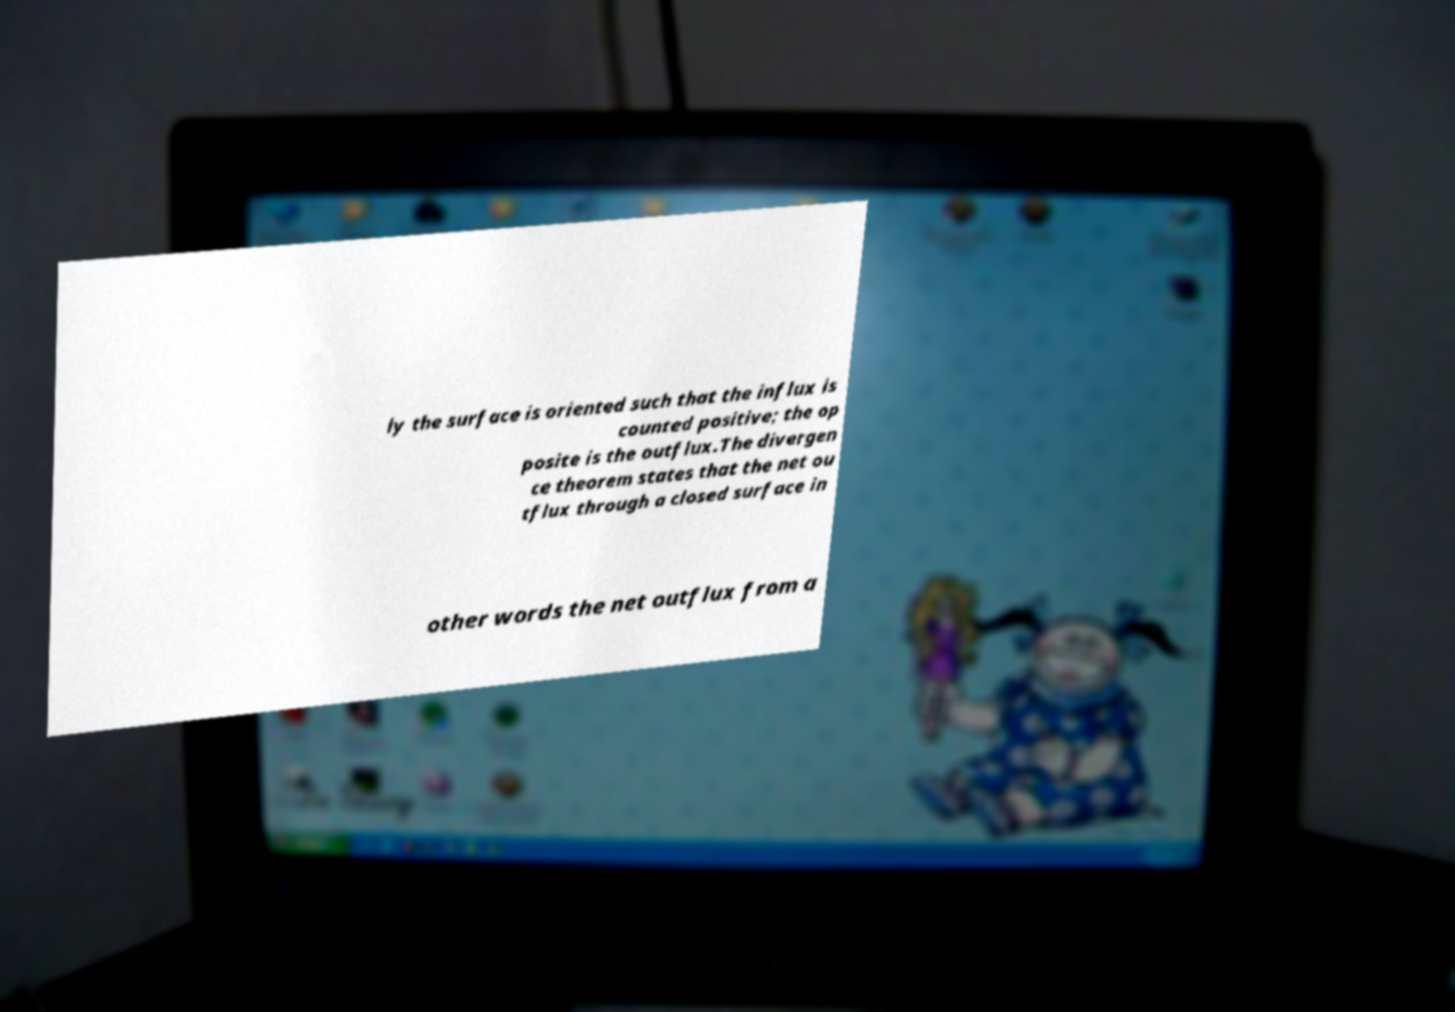Could you assist in decoding the text presented in this image and type it out clearly? ly the surface is oriented such that the influx is counted positive; the op posite is the outflux.The divergen ce theorem states that the net ou tflux through a closed surface in other words the net outflux from a 